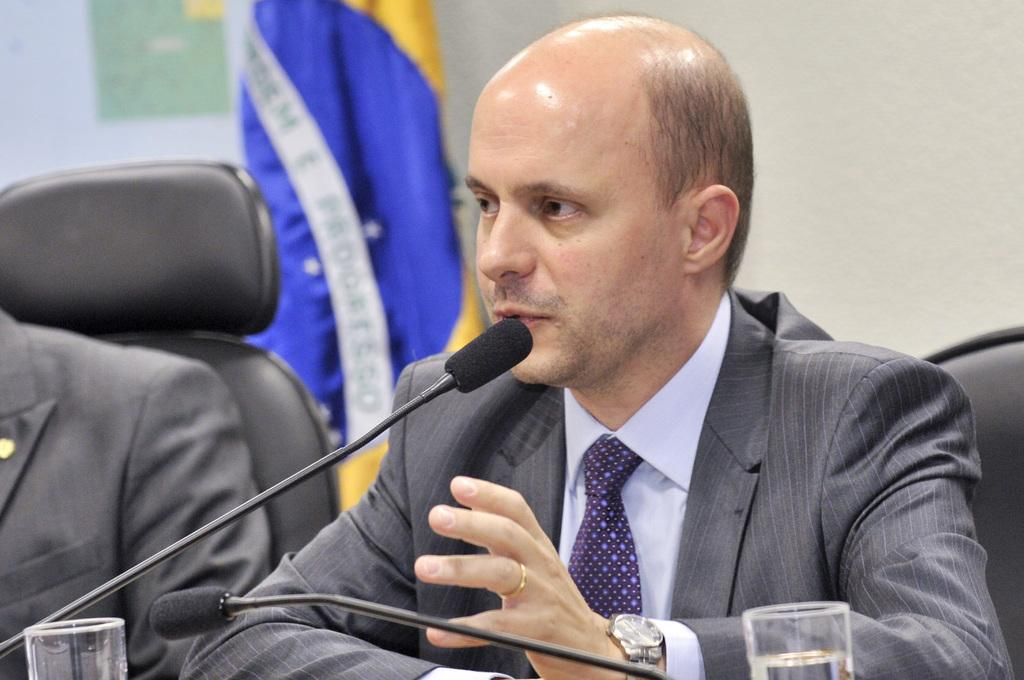How many people are sitting in the image? There are two persons sitting on chairs in the image. What is in front of the persons? There is a microphone and two glasses in front of the persons. What can be seen in the background of the image? There is a wall and a flag in the background of the image. What type of heart can be seen beating in the image? There is no heart visible in the image. Who is the creator of the flag in the background of the image? The creator of the flag is not mentioned in the image. 